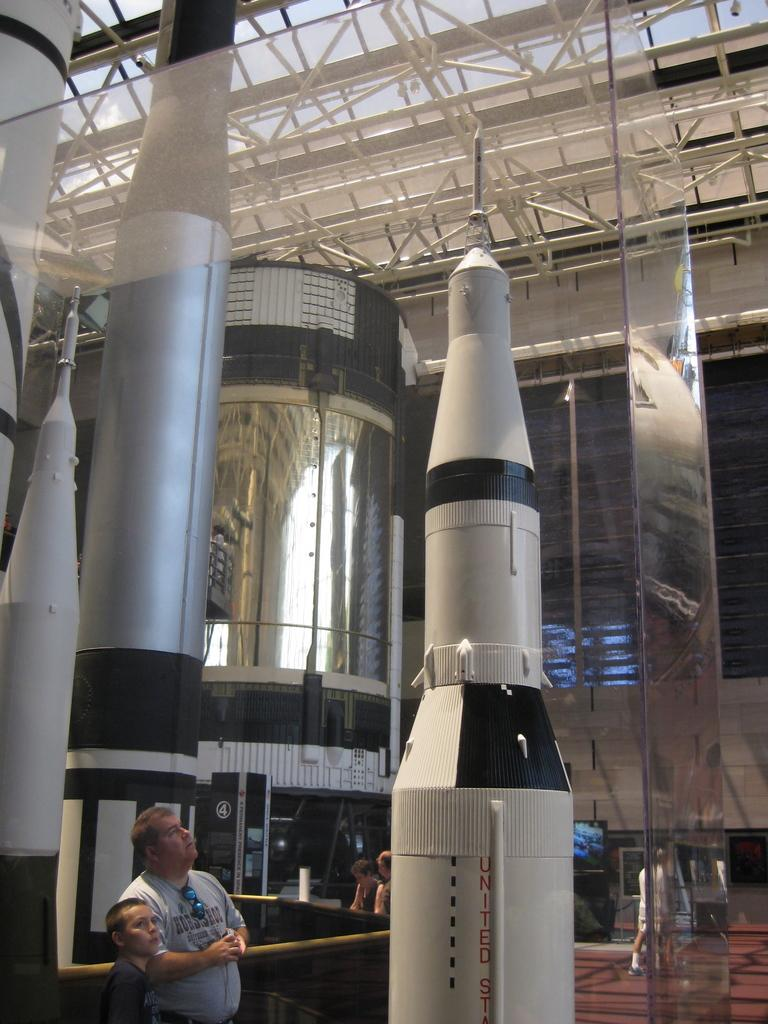What can be seen in the image involving a group of people? There is a group of people in the image. What type of objects are present that resemble rockets? There are replicas of rockets in the image. What materials can be seen in the background of the image? There are metal rods and glass in the background of the image. What is present in the background of the image that might display information? There is a screen in the background of the image. What type of pest can be seen crawling on the replicas of rockets in the image? There are no pests visible in the image, and no pests are mentioned in the provided facts. 